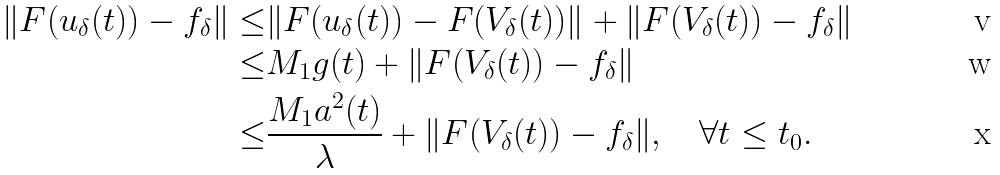Convert formula to latex. <formula><loc_0><loc_0><loc_500><loc_500>\| F ( u _ { \delta } ( t ) ) - f _ { \delta } \| \leq & \| F ( u _ { \delta } ( t ) ) - F ( V _ { \delta } ( t ) ) \| + \| F ( V _ { \delta } ( t ) ) - f _ { \delta } \| \\ \leq & M _ { 1 } g ( t ) + \| F ( V _ { \delta } ( t ) ) - f _ { \delta } \| \\ \leq & \frac { M _ { 1 } a ^ { 2 } ( t ) } { \lambda } + \| F ( V _ { \delta } ( t ) ) - f _ { \delta } \| , \quad \forall t \leq t _ { 0 } .</formula> 